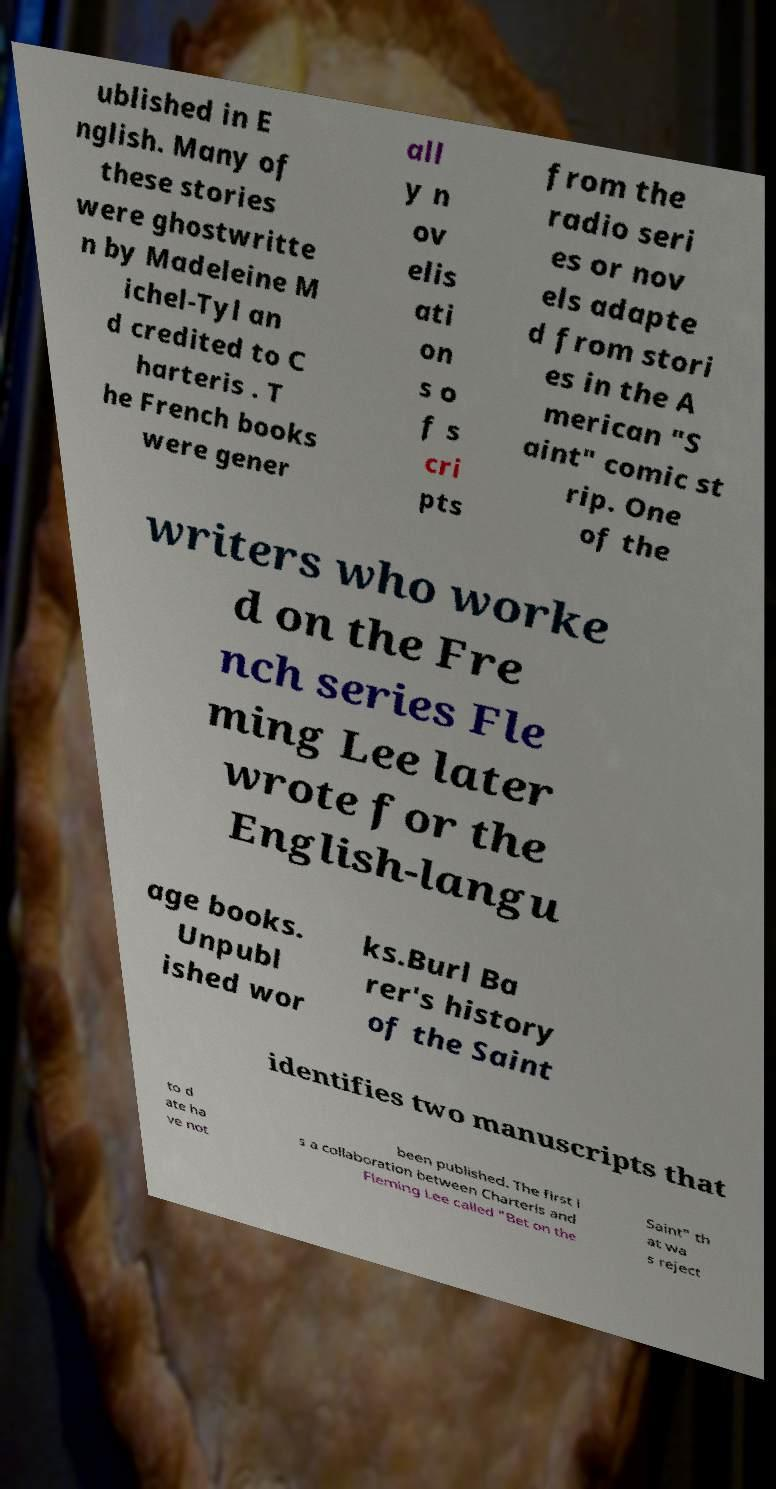For documentation purposes, I need the text within this image transcribed. Could you provide that? ublished in E nglish. Many of these stories were ghostwritte n by Madeleine M ichel-Tyl an d credited to C harteris . T he French books were gener all y n ov elis ati on s o f s cri pts from the radio seri es or nov els adapte d from stori es in the A merican "S aint" comic st rip. One of the writers who worke d on the Fre nch series Fle ming Lee later wrote for the English-langu age books. Unpubl ished wor ks.Burl Ba rer's history of the Saint identifies two manuscripts that to d ate ha ve not been published. The first i s a collaboration between Charteris and Fleming Lee called "Bet on the Saint" th at wa s reject 